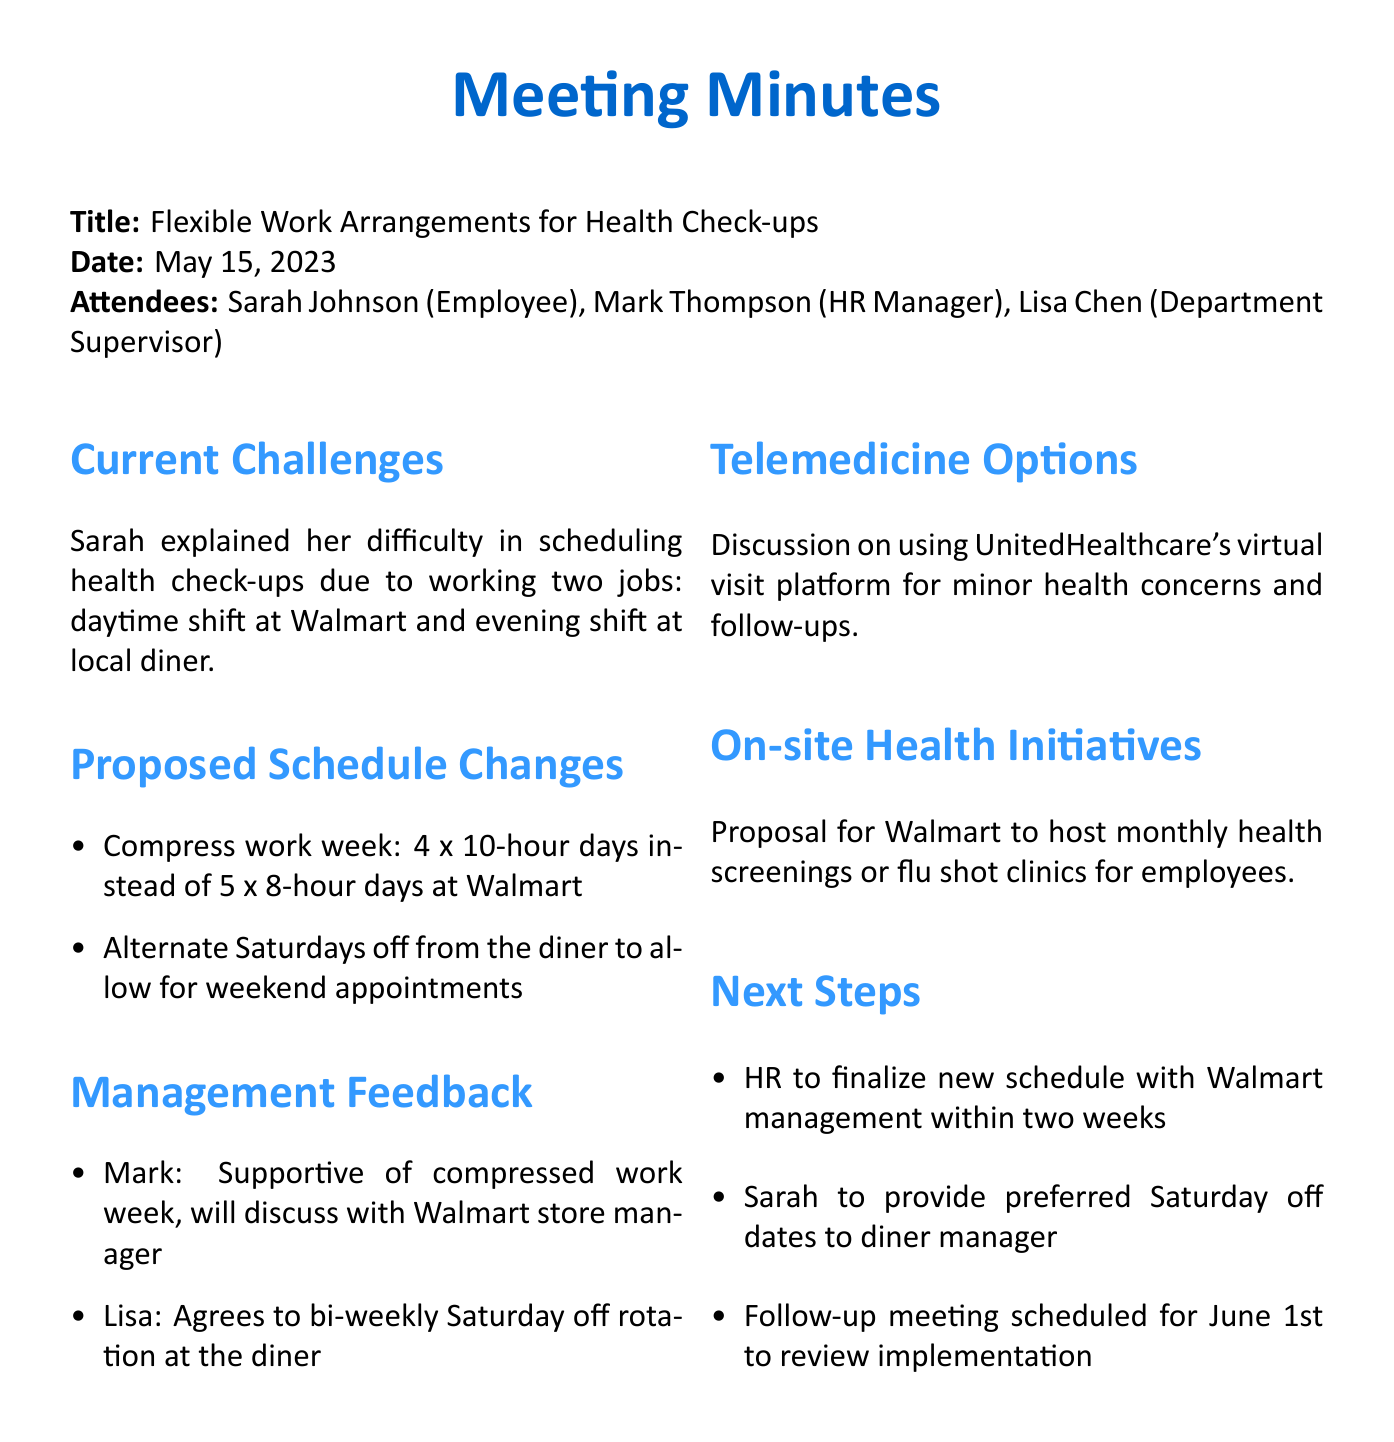what is the meeting title? The title of the meeting is explicitly stated at the beginning of the document.
Answer: Flexible Work Arrangements for Health Check-ups who are the attendees? The document lists all individuals who attended the meeting under the attendees section.
Answer: Sarah Johnson, Mark Thompson, Lisa Chen what date was the meeting held? The date of the meeting is mentioned right after the meeting title.
Answer: May 15, 2023 what proposed schedule changes were discussed? The proposed changes are summarized in the agenda item dedicated to that subject.
Answer: 4 x 10-hour days, alternate Saturdays off who is responsible for finalizing the new schedule? The document specifies the person who will handle the scheduling updates.
Answer: HR when is the follow-up meeting scheduled? The date for the follow-up meeting is noted under the next steps section for future reference.
Answer: June 1st what is the management's feedback on the compressed work week? The answers provided by management are highlighted in the management feedback section.
Answer: Supportive what health initiative was proposed for Walmart? The document describes a specific initiative aimed at promoting employee health.
Answer: Monthly health screenings or flu shot clinics what platform was discussed for telemedicine options? The document mentions a specific telemedicine platform in the relevant discussion section.
Answer: UnitedHealthcare's virtual visit platform 